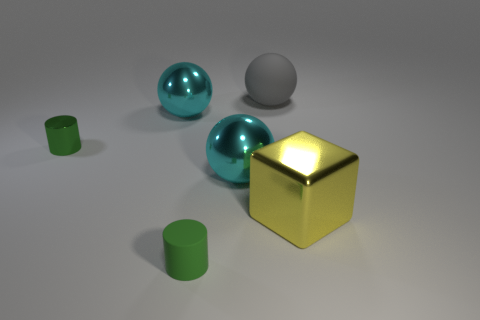Subtract all big metallic spheres. How many spheres are left? 1 Add 1 gray matte spheres. How many objects exist? 7 Subtract all gray spheres. How many spheres are left? 2 Subtract 0 yellow cylinders. How many objects are left? 6 Subtract all blocks. How many objects are left? 5 Subtract 1 blocks. How many blocks are left? 0 Subtract all yellow balls. Subtract all cyan cubes. How many balls are left? 3 Subtract all yellow cylinders. How many gray balls are left? 1 Subtract all large balls. Subtract all cyan balls. How many objects are left? 1 Add 4 small green things. How many small green things are left? 6 